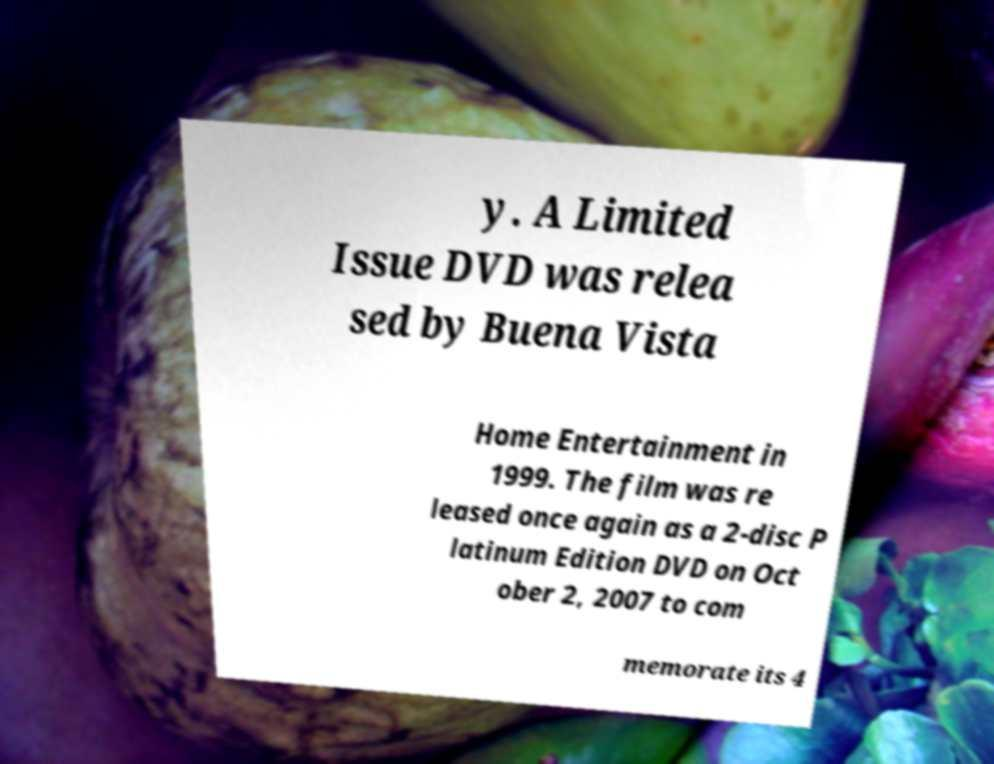There's text embedded in this image that I need extracted. Can you transcribe it verbatim? y. A Limited Issue DVD was relea sed by Buena Vista Home Entertainment in 1999. The film was re leased once again as a 2-disc P latinum Edition DVD on Oct ober 2, 2007 to com memorate its 4 